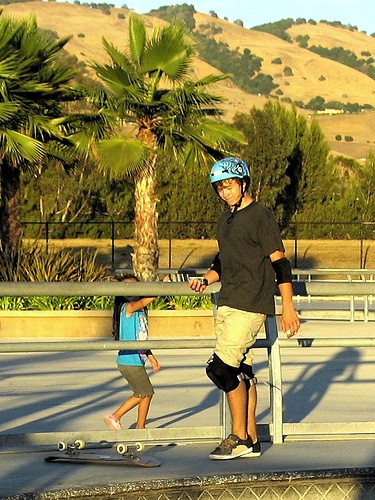Describe the objects in this image and their specific colors. I can see people in olive, black, khaki, and darkgreen tones, people in olive, black, turquoise, and orange tones, and skateboard in olive, gray, black, tan, and darkgreen tones in this image. 